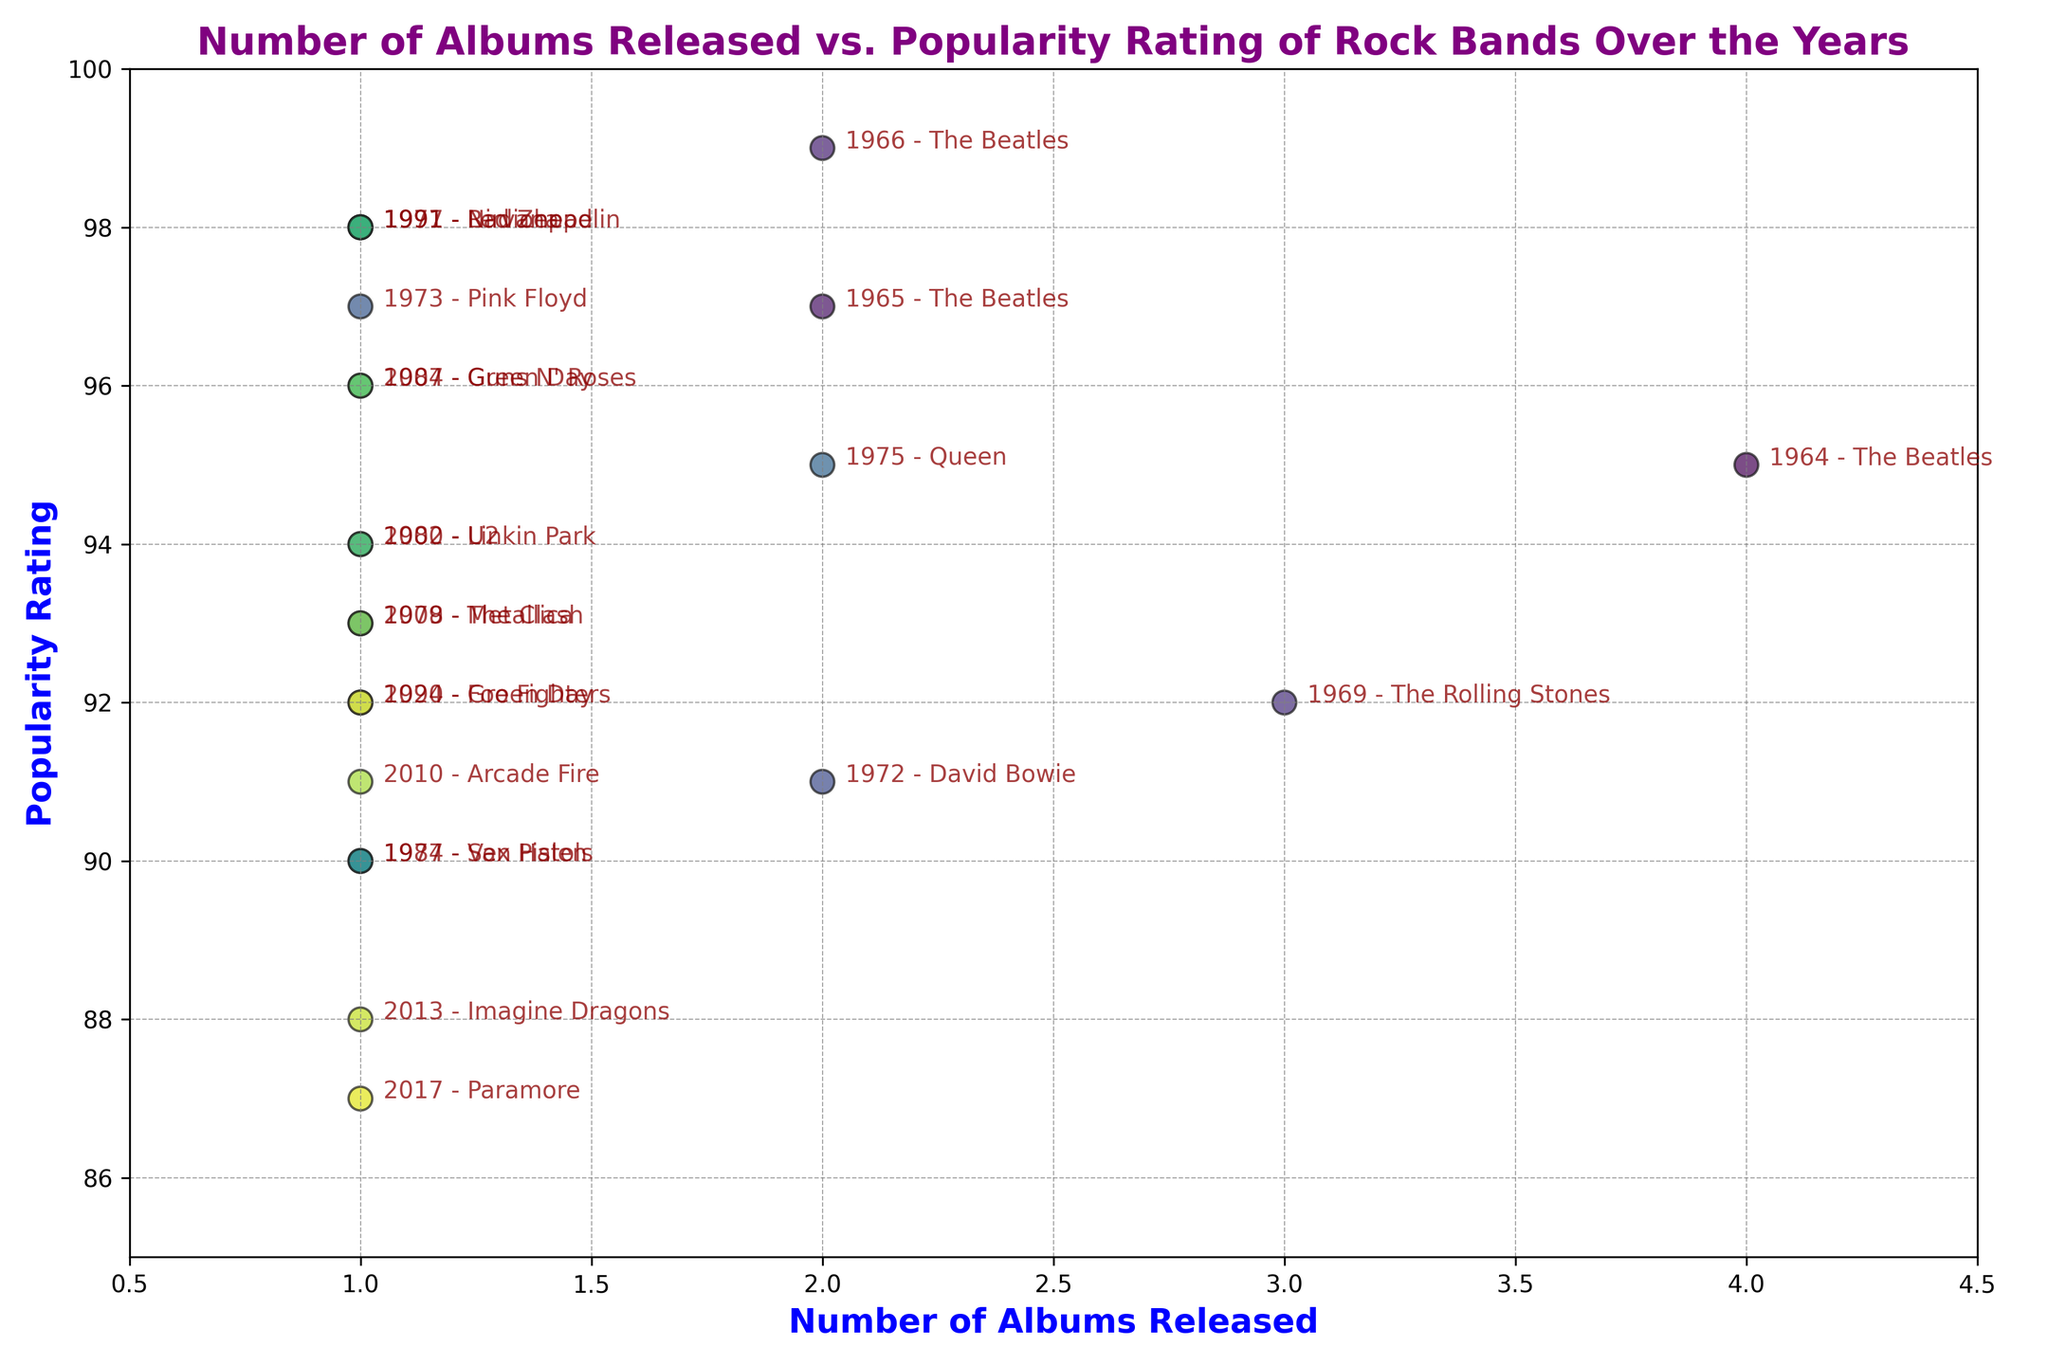What is the popularity rating of The Beatles in 1964? The label next to the point for 'The Beatles in 1964' indicates the year and band. The point is located at the coordinates with an x-value of 4 (number of albums) and a y-value of 95 (popularity rating).
Answer: 95 Which band had the highest popularity rating with only one album released? By looking at the points with x-value 1 (number of albums), the highest y-value (popularity rating) among them can be found. The point for 'Nirvana in 1991' has a y-value of 98.
Answer: Nirvana How many bands released more than one album between 1972 and 1975? Count the points with x-values greater than 1 (number of albums) in the mentioned years. 'David Bowie in 1972' and 'Queen in 1975' released 2 albums each.
Answer: 2 Which band had a higher popularity rating in 1991, Nirvana or Green Day? Compare the popularity ratings of the two points: 'Nirvana in 1991' (98) and 'Green Day in 1994' (92). Although Green Day is in 1994, it's the closest comparison to Nirvana in 1991 within available data.
Answer: Nirvana What is the average popularity rating of bands that released one album in the 2000s? Identify the points with an x-value of 1 (number of albums) in the 2000s: 'Linkin Park in 2000' (94), 'Green Day in 2004' (96), 'Metallica in 2008' (93), and 'Arcade Fire in 2010' (91). Calculate the average (94 + 96 + 93 + 91)/4.
Answer: 93.5 Which year had the highest collective popularity rating based on the sum of popularity ratings for all bands that released albums that year? Sum the popularity ratings for each year. For example, in 1964 (95), 1965 (97), and so on. The highest total comes from summing the points. Upon calculation (sample years to consider for higher values: 1964 (95) + 1965 (97) + 1966 (99) = 291 for The Beatles), one can detect the year with the maximum sum.
Answer: 1966 What trend can be observed in the popularity rating of The Beatles from 1964 to 1966? Observe the change in y-values for 'The Beatles' from 1964 to 1966: 95 in 1964, 97 in 1965, and 99 in 1966.
Answer: Increasing How does the popularity rating of The Rolling Stones in 1969 compare to Led Zeppelin in 1971? Compare the y-values for 'The Rolling Stones in 1969' (92) and 'Led Zeppelin in 1971' (98).
Answer: Led Zeppelin is higher 